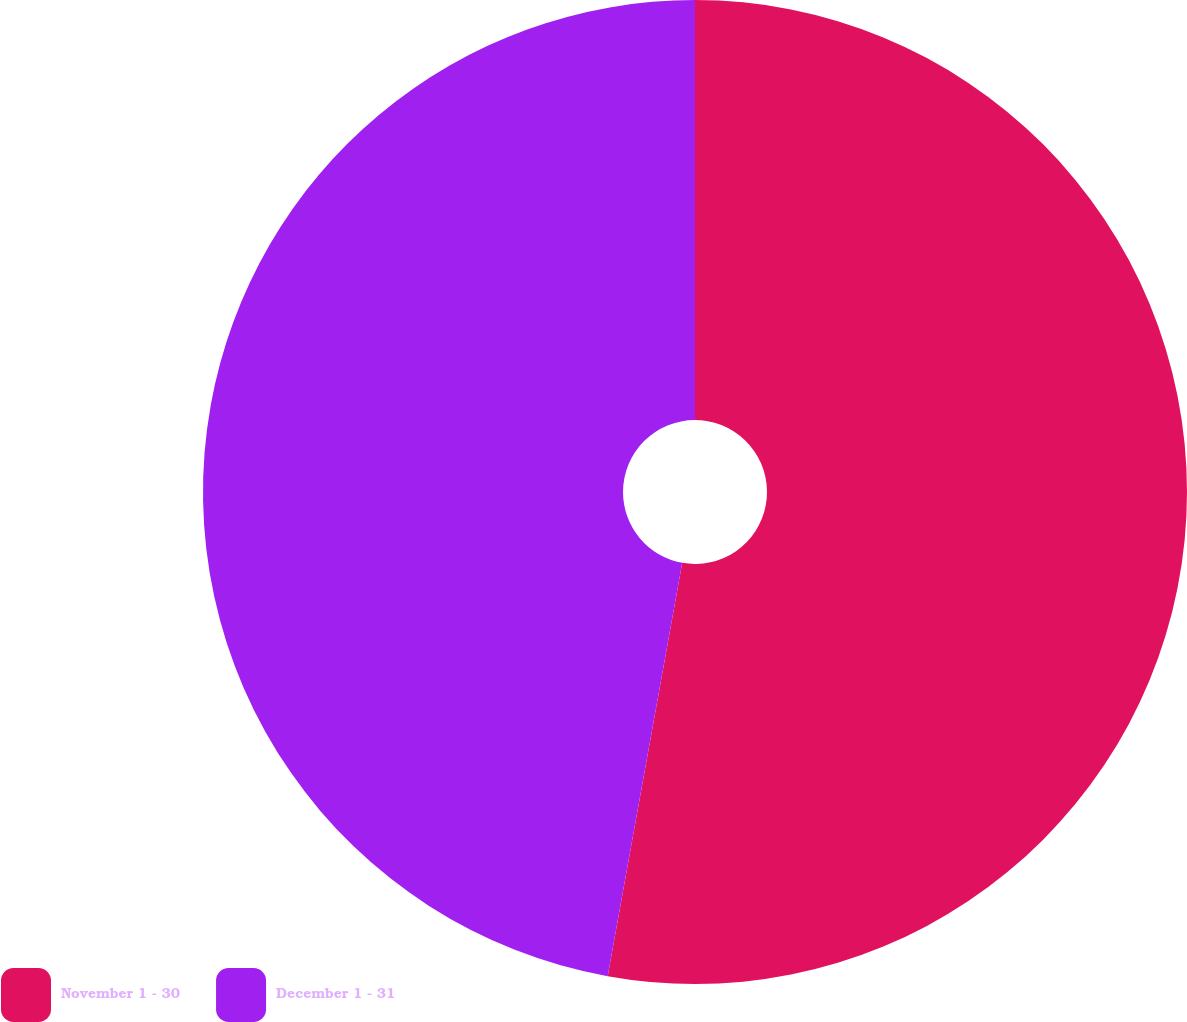<chart> <loc_0><loc_0><loc_500><loc_500><pie_chart><fcel>November 1 - 30<fcel>December 1 - 31<nl><fcel>52.84%<fcel>47.16%<nl></chart> 